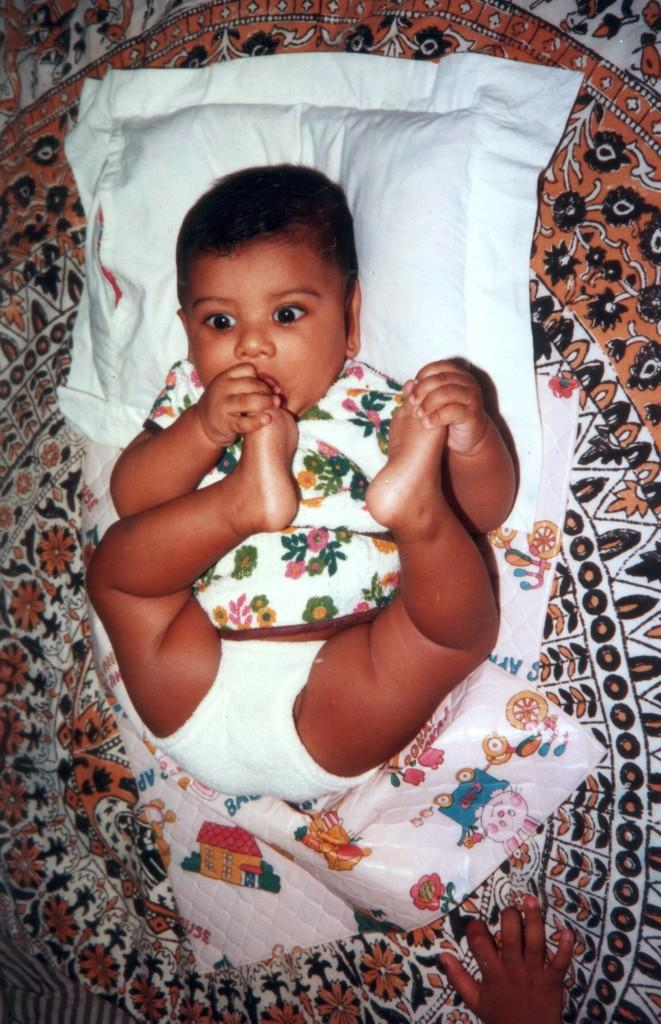What is the main subject of the image? There is a baby lying on a bed in the image. What else can be seen in the image besides the baby? There is a cushion in the image. Whose hand is visible in the image? A person's hand is visible in the image. Can you describe the setting of the image? The image is likely taken in a room. What invention is being used to lead the baby in the image? There is no invention or leading activity present in the image; it simply shows a baby lying on a bed with a cushion and a person's hand visible. 